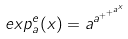Convert formula to latex. <formula><loc_0><loc_0><loc_500><loc_500>e x p _ { a } ^ { e } ( x ) = a ^ { a ^ { + ^ { + ^ { a ^ { x } } } } }</formula> 